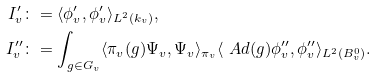<formula> <loc_0><loc_0><loc_500><loc_500>I _ { v } ^ { \prime } & \colon = \langle \phi _ { v } ^ { \prime } , \phi _ { v } ^ { \prime } \rangle _ { L ^ { 2 } ( k _ { v } ) } , \\ I _ { v } ^ { \prime \prime } & \colon = \int _ { g \in G _ { v } } \langle \pi _ { v } ( g ) \Psi _ { v } , \Psi _ { v } \rangle _ { \pi _ { v } } \langle \ A d ( g ) \phi _ { v } ^ { \prime \prime } , \phi _ { v } ^ { \prime \prime } \rangle _ { L ^ { 2 } ( B _ { v } ^ { 0 } ) } .</formula> 